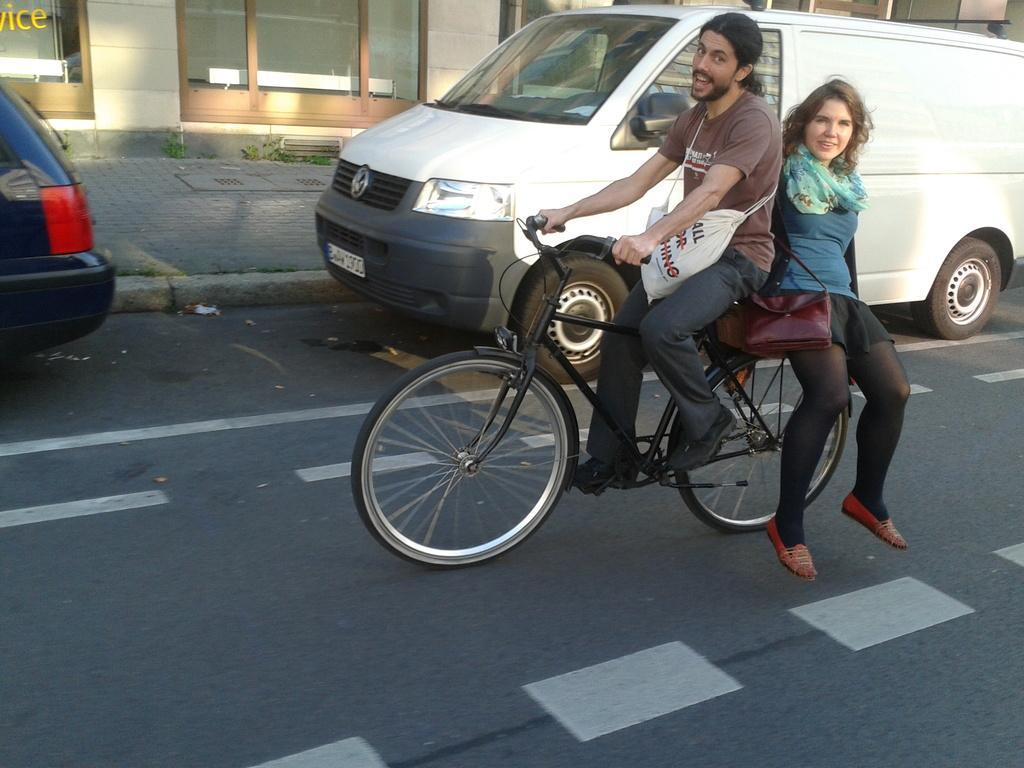How would you summarize this image in a sentence or two? This is the picture of 2 persons riding the bicycle and in the back ground there is a car , building and grass. 